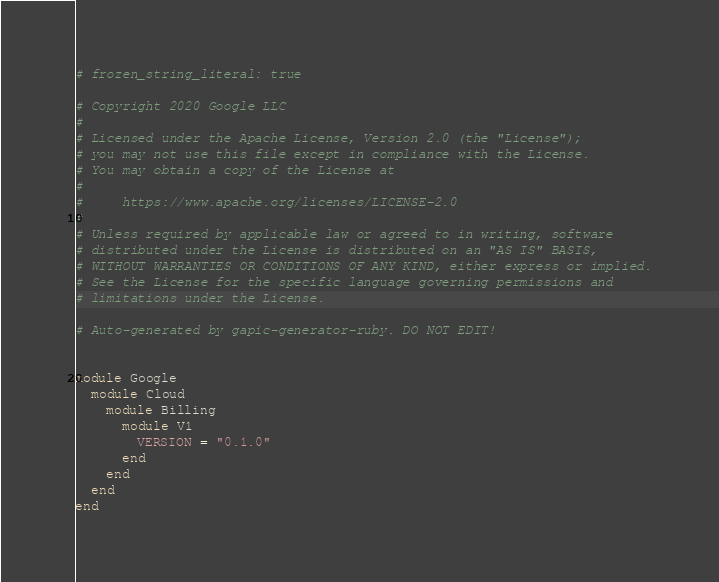Convert code to text. <code><loc_0><loc_0><loc_500><loc_500><_Ruby_># frozen_string_literal: true

# Copyright 2020 Google LLC
#
# Licensed under the Apache License, Version 2.0 (the "License");
# you may not use this file except in compliance with the License.
# You may obtain a copy of the License at
#
#     https://www.apache.org/licenses/LICENSE-2.0
#
# Unless required by applicable law or agreed to in writing, software
# distributed under the License is distributed on an "AS IS" BASIS,
# WITHOUT WARRANTIES OR CONDITIONS OF ANY KIND, either express or implied.
# See the License for the specific language governing permissions and
# limitations under the License.

# Auto-generated by gapic-generator-ruby. DO NOT EDIT!


module Google
  module Cloud
    module Billing
      module V1
        VERSION = "0.1.0"
      end
    end
  end
end
</code> 